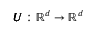Convert formula to latex. <formula><loc_0><loc_0><loc_500><loc_500>\pm b { U } \colon \mathbb { R } ^ { d } \rightarrow \mathbb { R } ^ { d }</formula> 